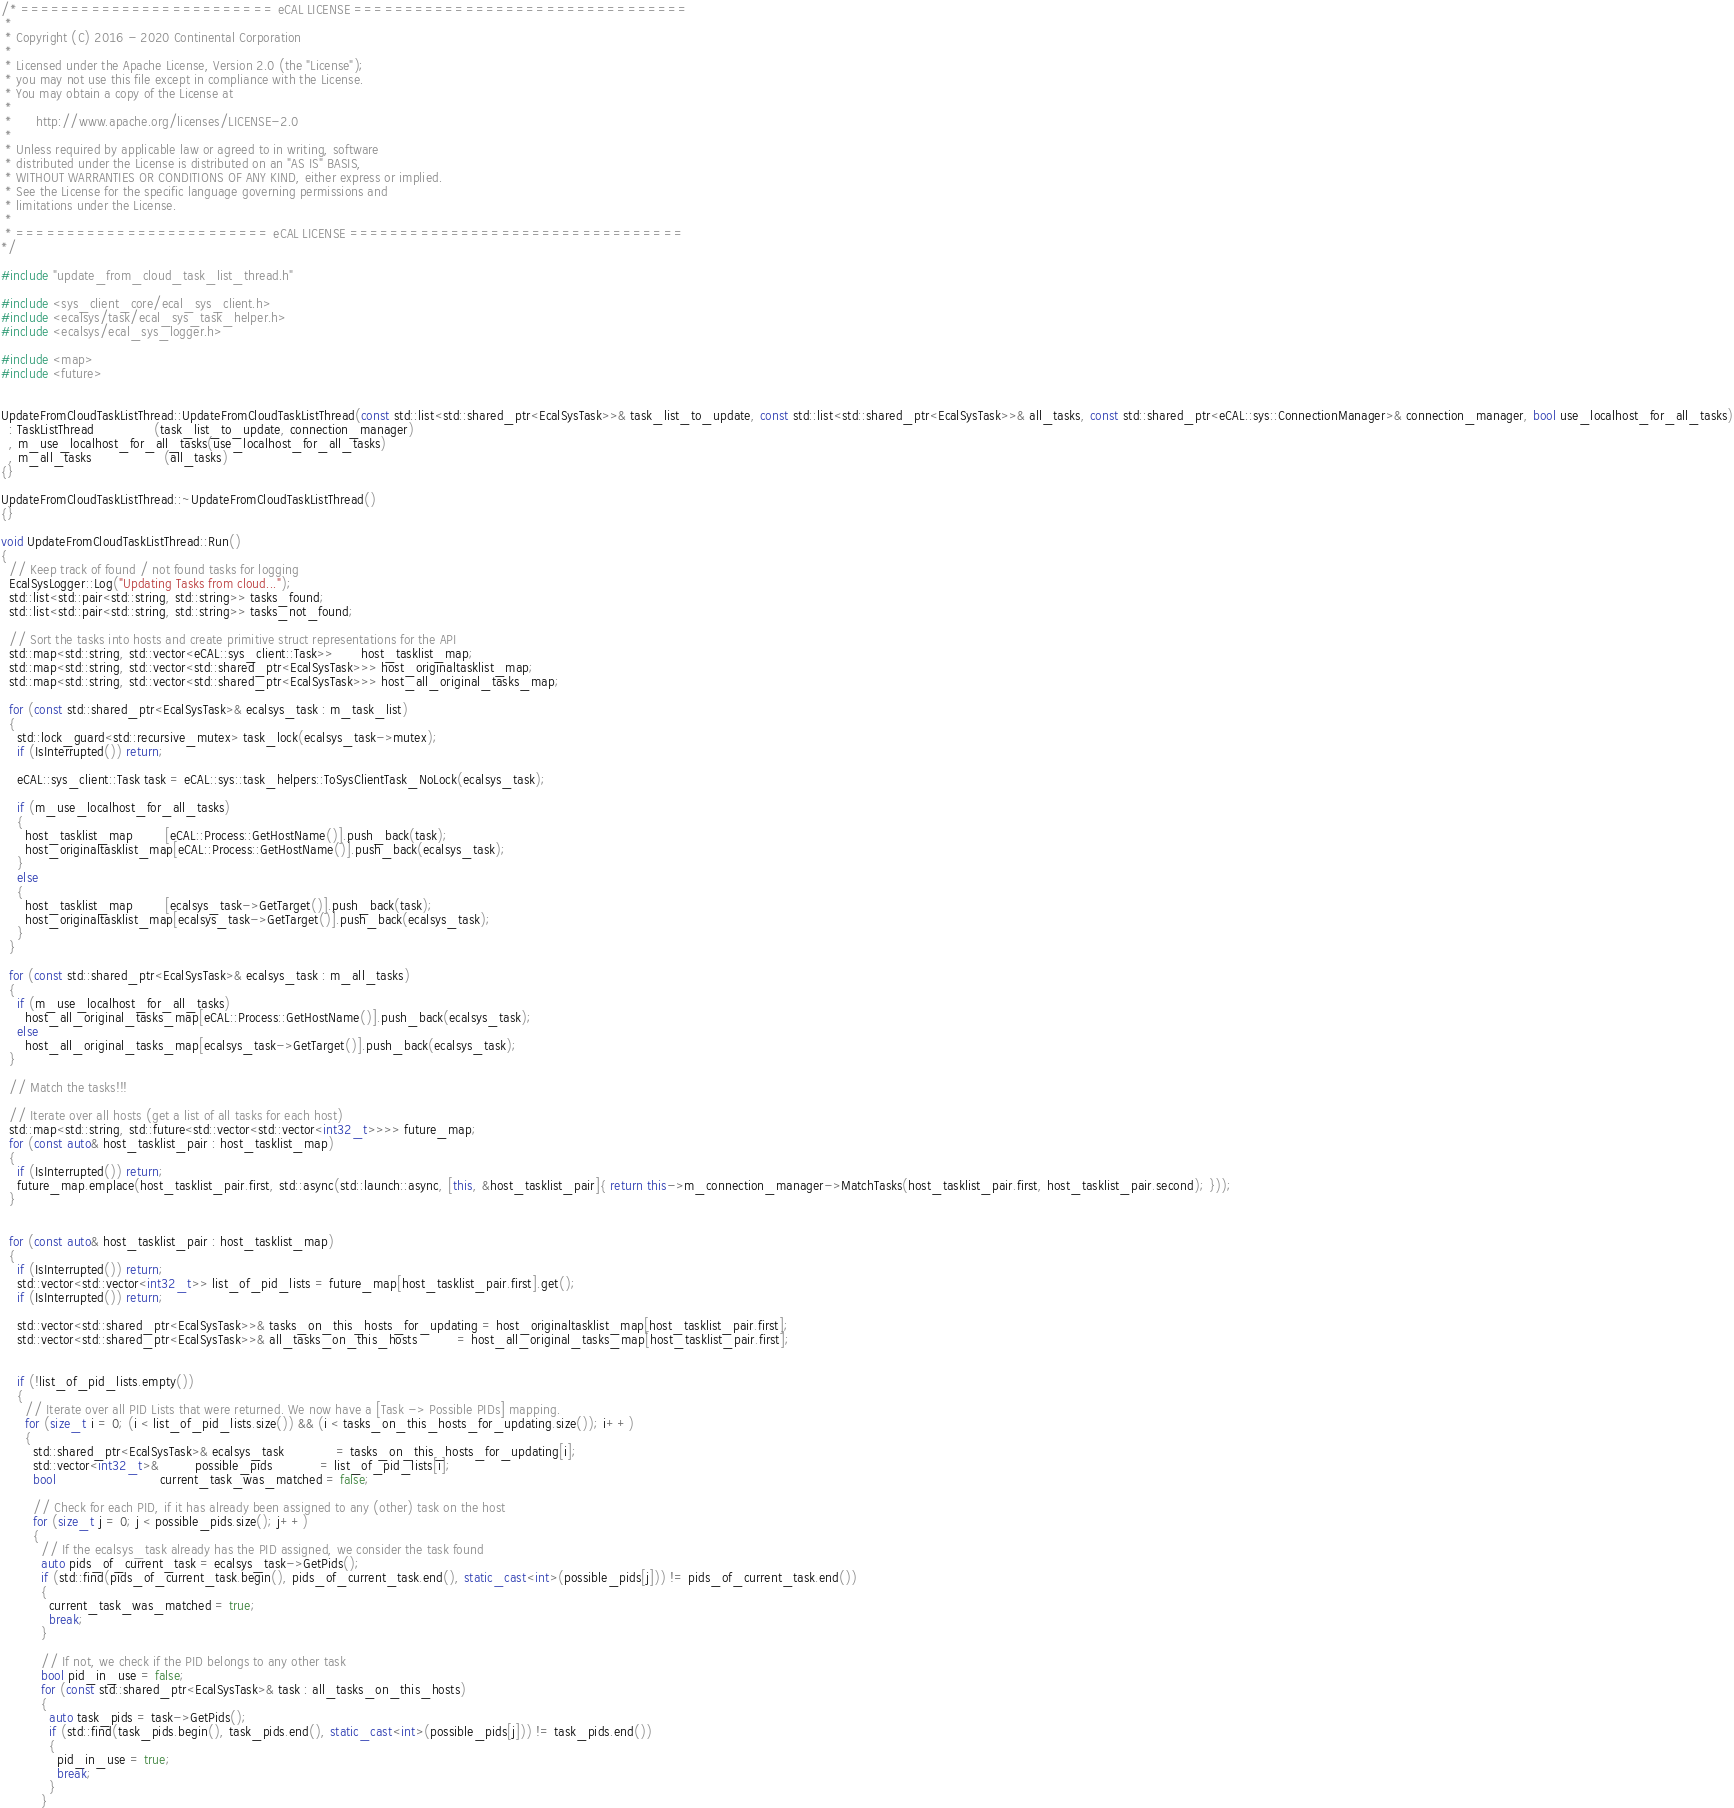Convert code to text. <code><loc_0><loc_0><loc_500><loc_500><_C++_>/* ========================= eCAL LICENSE =================================
 *
 * Copyright (C) 2016 - 2020 Continental Corporation
 *
 * Licensed under the Apache License, Version 2.0 (the "License");
 * you may not use this file except in compliance with the License.
 * You may obtain a copy of the License at
 * 
 *      http://www.apache.org/licenses/LICENSE-2.0
 * 
 * Unless required by applicable law or agreed to in writing, software
 * distributed under the License is distributed on an "AS IS" BASIS,
 * WITHOUT WARRANTIES OR CONDITIONS OF ANY KIND, either express or implied.
 * See the License for the specific language governing permissions and
 * limitations under the License.
 *
 * ========================= eCAL LICENSE =================================
*/

#include "update_from_cloud_task_list_thread.h"

#include <sys_client_core/ecal_sys_client.h>
#include <ecalsys/task/ecal_sys_task_helper.h>
#include <ecalsys/ecal_sys_logger.h>

#include <map>
#include <future>


UpdateFromCloudTaskListThread::UpdateFromCloudTaskListThread(const std::list<std::shared_ptr<EcalSysTask>>& task_list_to_update, const std::list<std::shared_ptr<EcalSysTask>>& all_tasks, const std::shared_ptr<eCAL::sys::ConnectionManager>& connection_manager, bool use_localhost_for_all_tasks)
  : TaskListThread               (task_list_to_update, connection_manager)
  , m_use_localhost_for_all_tasks(use_localhost_for_all_tasks)
  , m_all_tasks                  (all_tasks)
{}

UpdateFromCloudTaskListThread::~UpdateFromCloudTaskListThread()
{}

void UpdateFromCloudTaskListThread::Run()
{
  // Keep track of found / not found tasks for logging
  EcalSysLogger::Log("Updating Tasks from cloud...");
  std::list<std::pair<std::string, std::string>> tasks_found;
  std::list<std::pair<std::string, std::string>> tasks_not_found;

  // Sort the tasks into hosts and create primitive struct representations for the API
  std::map<std::string, std::vector<eCAL::sys_client::Task>>       host_tasklist_map;
  std::map<std::string, std::vector<std::shared_ptr<EcalSysTask>>> host_originaltasklist_map;
  std::map<std::string, std::vector<std::shared_ptr<EcalSysTask>>> host_all_original_tasks_map;

  for (const std::shared_ptr<EcalSysTask>& ecalsys_task : m_task_list)
  {
    std::lock_guard<std::recursive_mutex> task_lock(ecalsys_task->mutex);
    if (IsInterrupted()) return;

    eCAL::sys_client::Task task = eCAL::sys::task_helpers::ToSysClientTask_NoLock(ecalsys_task);

    if (m_use_localhost_for_all_tasks)
    {
      host_tasklist_map        [eCAL::Process::GetHostName()].push_back(task);
      host_originaltasklist_map[eCAL::Process::GetHostName()].push_back(ecalsys_task);
    }
    else
    {
      host_tasklist_map        [ecalsys_task->GetTarget()].push_back(task);
      host_originaltasklist_map[ecalsys_task->GetTarget()].push_back(ecalsys_task);
    }
  }

  for (const std::shared_ptr<EcalSysTask>& ecalsys_task : m_all_tasks)
  {
    if (m_use_localhost_for_all_tasks)
      host_all_original_tasks_map[eCAL::Process::GetHostName()].push_back(ecalsys_task);
    else
      host_all_original_tasks_map[ecalsys_task->GetTarget()].push_back(ecalsys_task);
  }

  // Match the tasks!!!

  // Iterate over all hosts (get a list of all tasks for each host)
  std::map<std::string, std::future<std::vector<std::vector<int32_t>>>> future_map;
  for (const auto& host_tasklist_pair : host_tasklist_map)
  {
    if (IsInterrupted()) return;
    future_map.emplace(host_tasklist_pair.first, std::async(std::launch::async, [this, &host_tasklist_pair]{ return this->m_connection_manager->MatchTasks(host_tasklist_pair.first, host_tasklist_pair.second); }));
  }


  for (const auto& host_tasklist_pair : host_tasklist_map)
  {
    if (IsInterrupted()) return;
    std::vector<std::vector<int32_t>> list_of_pid_lists = future_map[host_tasklist_pair.first].get();
    if (IsInterrupted()) return;

    std::vector<std::shared_ptr<EcalSysTask>>& tasks_on_this_hosts_for_updating = host_originaltasklist_map[host_tasklist_pair.first];
    std::vector<std::shared_ptr<EcalSysTask>>& all_tasks_on_this_hosts          = host_all_original_tasks_map[host_tasklist_pair.first];


    if (!list_of_pid_lists.empty())
    {
      // Iterate over all PID Lists that were returned. We now have a [Task -> Possible PIDs] mapping.
      for (size_t i = 0; (i < list_of_pid_lists.size()) && (i < tasks_on_this_hosts_for_updating.size()); i++)
      {
        std::shared_ptr<EcalSysTask>& ecalsys_task             = tasks_on_this_hosts_for_updating[i];
        std::vector<int32_t>&         possible_pids            = list_of_pid_lists[i];
        bool                          current_task_was_matched = false;

        // Check for each PID, if it has already been assigned to any (other) task on the host
        for (size_t j = 0; j < possible_pids.size(); j++)
        {
          // If the ecalsys_task already has the PID assigned, we consider the task found
          auto pids_of_current_task = ecalsys_task->GetPids();
          if (std::find(pids_of_current_task.begin(), pids_of_current_task.end(), static_cast<int>(possible_pids[j])) != pids_of_current_task.end())
          {
            current_task_was_matched = true;
            break;
          }

          // If not, we check if the PID belongs to any other task
          bool pid_in_use = false;
          for (const std::shared_ptr<EcalSysTask>& task : all_tasks_on_this_hosts)
          {
            auto task_pids = task->GetPids();
            if (std::find(task_pids.begin(), task_pids.end(), static_cast<int>(possible_pids[j])) != task_pids.end())
            {
              pid_in_use = true;
              break;
            }
          }
</code> 